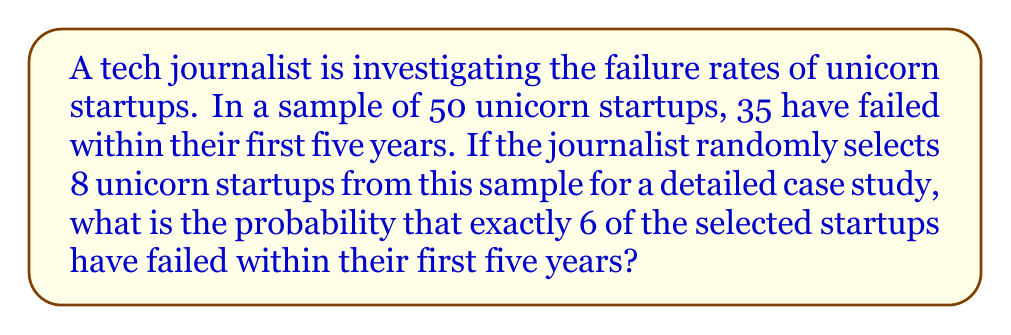Solve this math problem. To solve this problem, we can use the hypergeometric distribution, which is appropriate for sampling without replacement from a finite population.

Let's define our parameters:
$N = 50$ (total number of unicorn startups in the sample)
$K = 35$ (number of failed startups)
$n = 8$ (number of startups selected for the case study)
$k = 6$ (number of failed startups we want in our selection)

The probability mass function for the hypergeometric distribution is:

$$ P(X = k) = \frac{\binom{K}{k} \binom{N-K}{n-k}}{\binom{N}{n}} $$

Substituting our values:

$$ P(X = 6) = \frac{\binom{35}{6} \binom{50-35}{8-6}}{\binom{50}{8}} $$

Now, let's calculate each combination:

1) $\binom{35}{6} = 1,623,160$
2) $\binom{15}{2} = 105$
3) $\binom{50}{8} = 536,878,650$

Substituting these values:

$$ P(X = 6) = \frac{1,623,160 \times 105}{536,878,650} $$

$$ P(X = 6) = \frac{170,431,800}{536,878,650} $$

$$ P(X = 6) = 0.3174 $$

Therefore, the probability is approximately 0.3174 or 31.74%.
Answer: 0.3174 